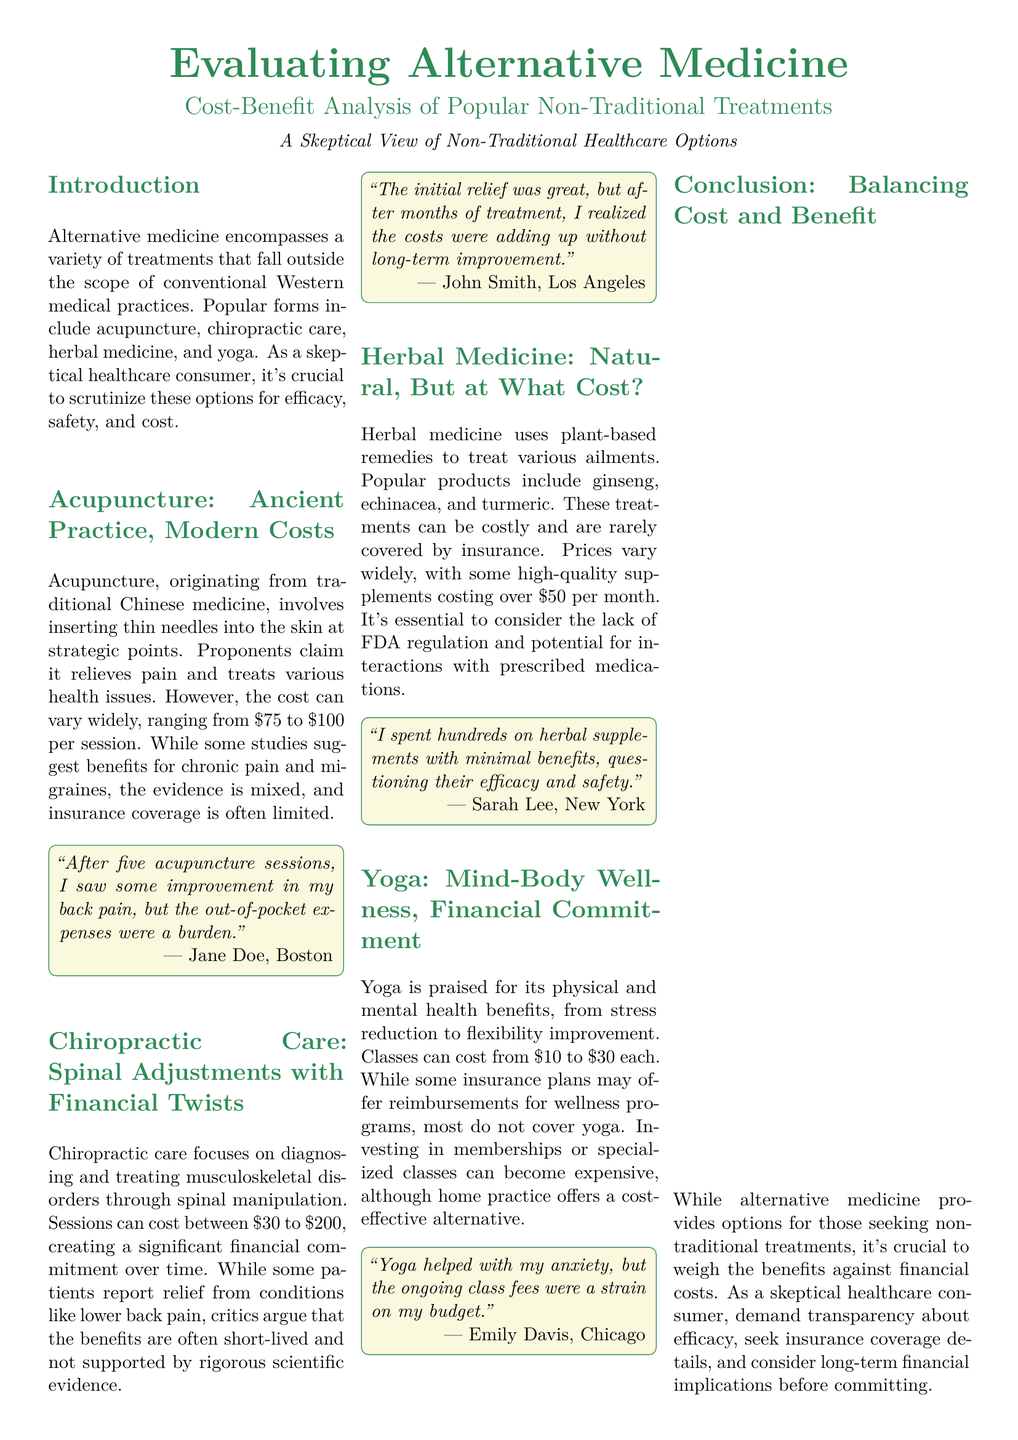What is the cost range for acupuncture sessions? The document states the cost can vary widely, ranging from $75 to $100 per session.
Answer: $75 to $100 What percentage of Americans have used alternative therapy? The document specifies that 47% of Americans have used at least one form of alternative therapy.
Answer: 47% What are two popular forms of alternative medicine mentioned? The document lists acupuncture and chiropractic care as two popular forms of alternative medicine.
Answer: Acupuncture and chiropractic care According to the document, how much do Americans spend annually on alternative medicine? The document states that Americans spend $34 billion annually on alternative medicine.
Answer: $34 billion What is a key financial issue related to chiropractic care? The document highlights that sessions can cost between $30 to $200, indicating a significant financial commitment over time.
Answer: Significant financial commitment Which treatment’s expenses are rarely covered by insurance? The document mentions that herbal medicine is rarely covered by insurance.
Answer: Herbal medicine What is one of the main benefits of yoga as per the document? The document notes that yoga is praised for its physical and mental health benefits, including stress reduction.
Answer: Stress reduction What is a recommendation for evaluating alternative treatments? The document suggests consulting with a licensed healthcare provider before starting any new treatment.
Answer: Consult with a licensed healthcare provider What is one perspective shared by a person regarding acupuncture's effectiveness? The document includes a quote indicating improved back pain after sessions, but acknowledges the burden of expenses.
Answer: Improvement in back pain 